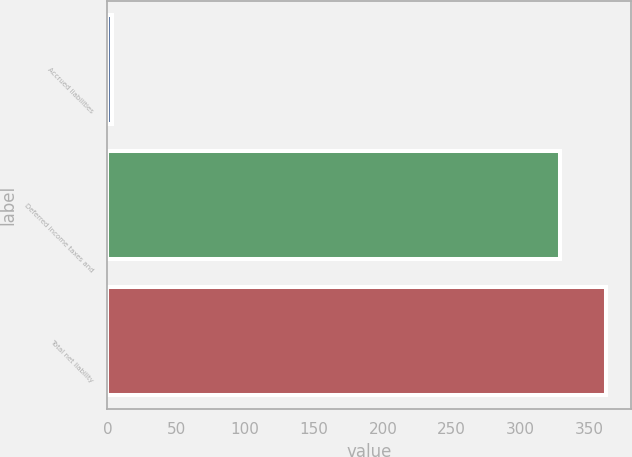Convert chart. <chart><loc_0><loc_0><loc_500><loc_500><bar_chart><fcel>Accrued liabilities<fcel>Deferred income taxes and<fcel>Total net liability<nl><fcel>3<fcel>329<fcel>361.9<nl></chart> 